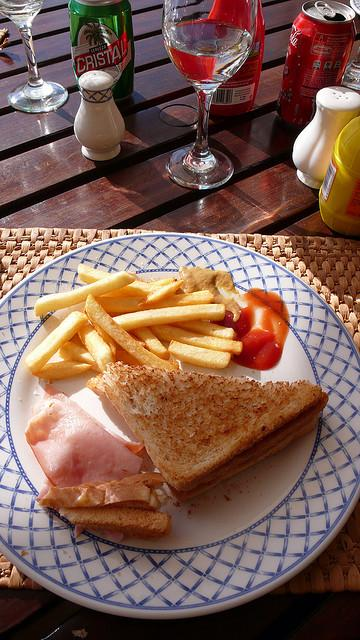Where was this sandwich likely cooked? restaurant 